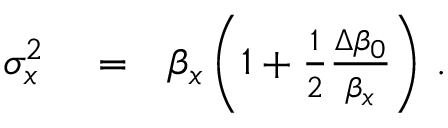Convert formula to latex. <formula><loc_0><loc_0><loc_500><loc_500>\begin{array} { r l r } { \sigma _ { x } ^ { 2 } } & = } & { \beta _ { x } \left ( 1 + \frac { 1 } { 2 } \frac { \Delta \beta _ { 0 } } { \beta _ { x } } \right ) \, . } \end{array}</formula> 